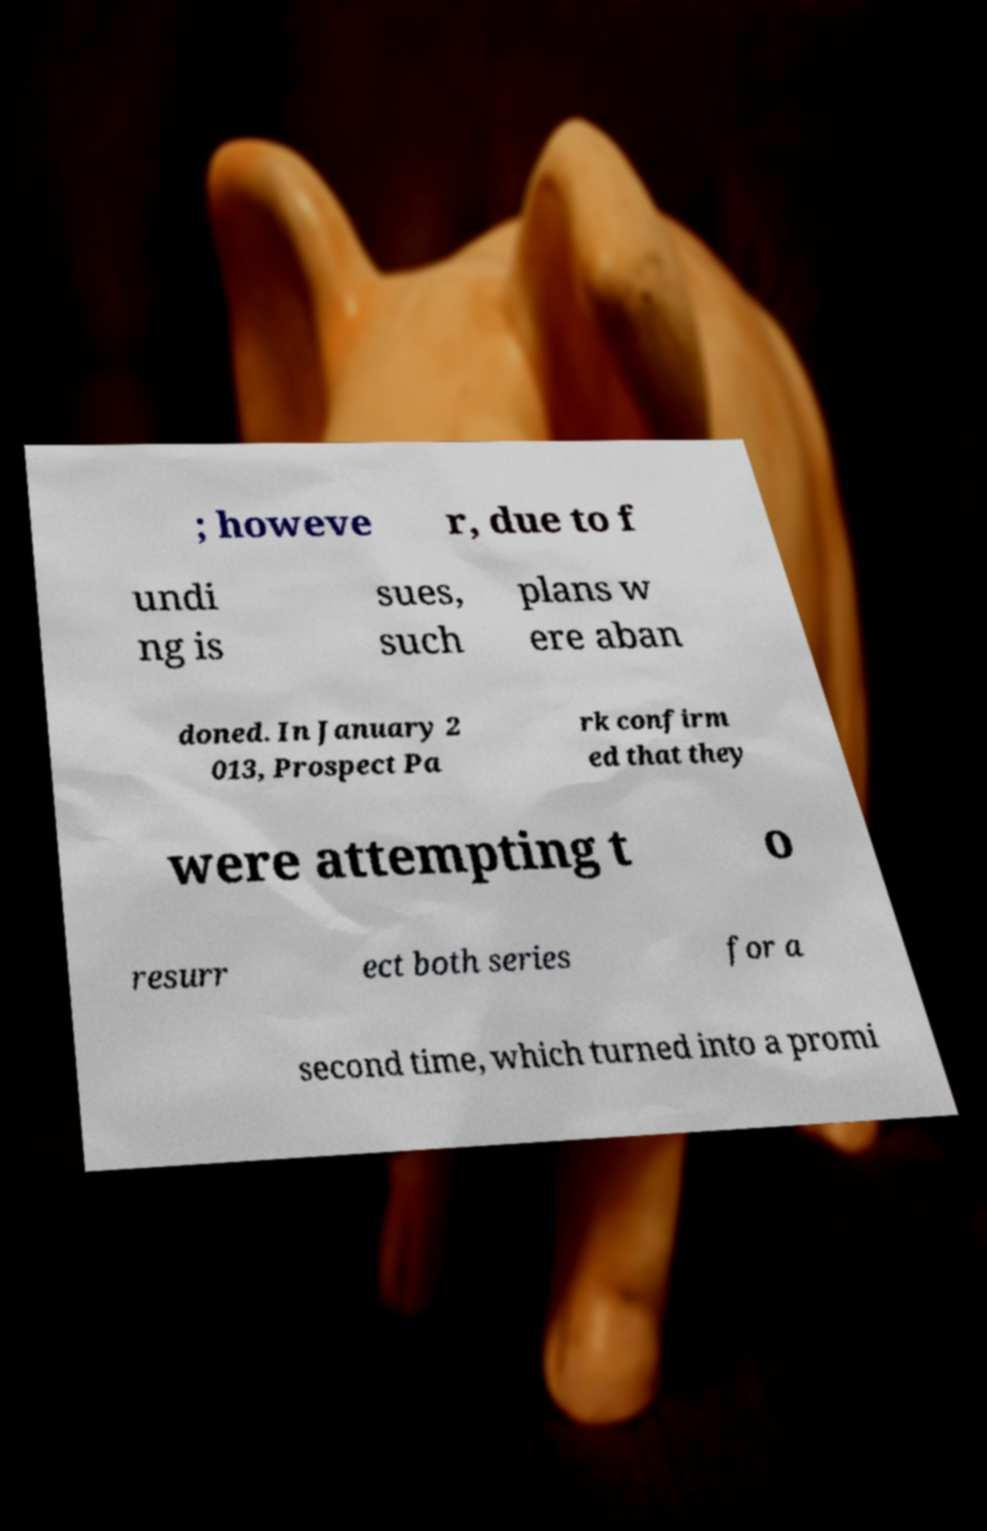Can you accurately transcribe the text from the provided image for me? ; howeve r, due to f undi ng is sues, such plans w ere aban doned. In January 2 013, Prospect Pa rk confirm ed that they were attempting t o resurr ect both series for a second time, which turned into a promi 